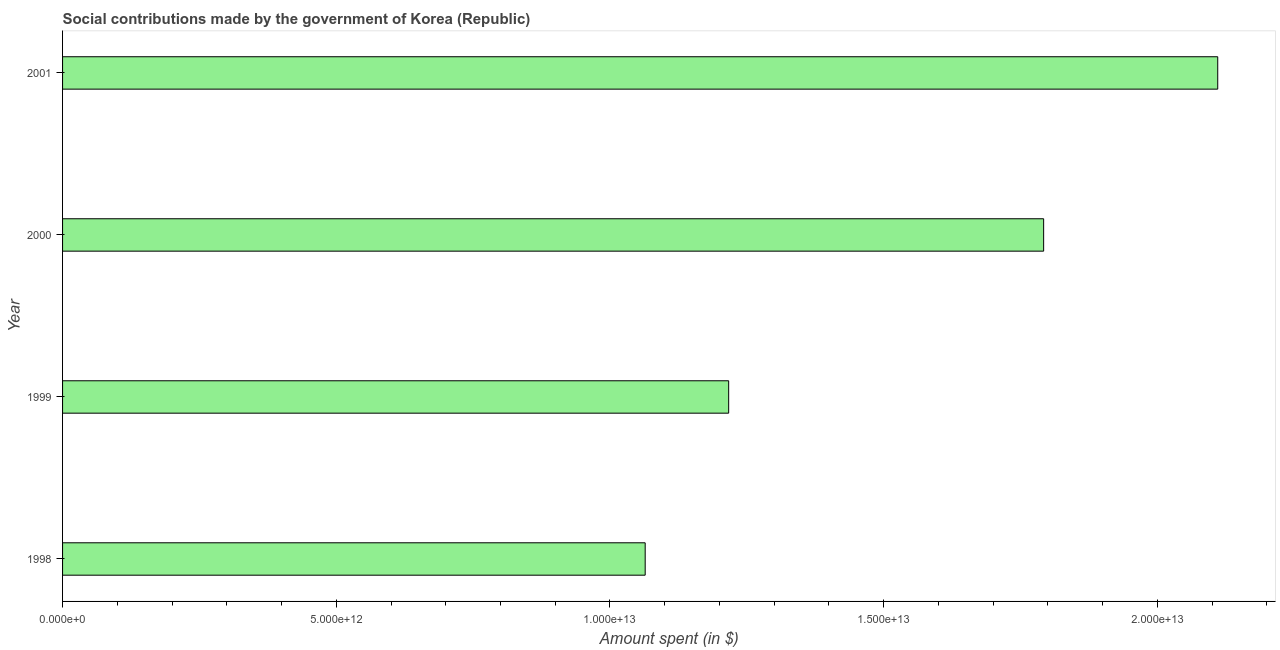Does the graph contain any zero values?
Make the answer very short. No. What is the title of the graph?
Provide a short and direct response. Social contributions made by the government of Korea (Republic). What is the label or title of the X-axis?
Offer a terse response. Amount spent (in $). What is the amount spent in making social contributions in 2001?
Give a very brief answer. 2.11e+13. Across all years, what is the maximum amount spent in making social contributions?
Your answer should be compact. 2.11e+13. Across all years, what is the minimum amount spent in making social contributions?
Ensure brevity in your answer.  1.06e+13. In which year was the amount spent in making social contributions minimum?
Offer a terse response. 1998. What is the sum of the amount spent in making social contributions?
Make the answer very short. 6.18e+13. What is the difference between the amount spent in making social contributions in 1998 and 1999?
Provide a succinct answer. -1.53e+12. What is the average amount spent in making social contributions per year?
Your answer should be compact. 1.55e+13. What is the median amount spent in making social contributions?
Offer a very short reply. 1.50e+13. In how many years, is the amount spent in making social contributions greater than 15000000000000 $?
Give a very brief answer. 2. Do a majority of the years between 1998 and 2000 (inclusive) have amount spent in making social contributions greater than 21000000000000 $?
Keep it short and to the point. No. What is the ratio of the amount spent in making social contributions in 1999 to that in 2000?
Ensure brevity in your answer.  0.68. Is the difference between the amount spent in making social contributions in 1998 and 2001 greater than the difference between any two years?
Give a very brief answer. Yes. What is the difference between the highest and the second highest amount spent in making social contributions?
Keep it short and to the point. 3.18e+12. Is the sum of the amount spent in making social contributions in 2000 and 2001 greater than the maximum amount spent in making social contributions across all years?
Your answer should be compact. Yes. What is the difference between the highest and the lowest amount spent in making social contributions?
Ensure brevity in your answer.  1.05e+13. Are all the bars in the graph horizontal?
Offer a very short reply. Yes. What is the difference between two consecutive major ticks on the X-axis?
Your answer should be compact. 5.00e+12. Are the values on the major ticks of X-axis written in scientific E-notation?
Provide a short and direct response. Yes. What is the Amount spent (in $) in 1998?
Provide a succinct answer. 1.06e+13. What is the Amount spent (in $) in 1999?
Your answer should be compact. 1.22e+13. What is the Amount spent (in $) in 2000?
Ensure brevity in your answer.  1.79e+13. What is the Amount spent (in $) of 2001?
Your answer should be very brief. 2.11e+13. What is the difference between the Amount spent (in $) in 1998 and 1999?
Your answer should be compact. -1.53e+12. What is the difference between the Amount spent (in $) in 1998 and 2000?
Your answer should be compact. -7.28e+12. What is the difference between the Amount spent (in $) in 1998 and 2001?
Keep it short and to the point. -1.05e+13. What is the difference between the Amount spent (in $) in 1999 and 2000?
Your answer should be compact. -5.75e+12. What is the difference between the Amount spent (in $) in 1999 and 2001?
Offer a terse response. -8.93e+12. What is the difference between the Amount spent (in $) in 2000 and 2001?
Your answer should be very brief. -3.18e+12. What is the ratio of the Amount spent (in $) in 1998 to that in 1999?
Ensure brevity in your answer.  0.88. What is the ratio of the Amount spent (in $) in 1998 to that in 2000?
Ensure brevity in your answer.  0.59. What is the ratio of the Amount spent (in $) in 1998 to that in 2001?
Your response must be concise. 0.5. What is the ratio of the Amount spent (in $) in 1999 to that in 2000?
Your response must be concise. 0.68. What is the ratio of the Amount spent (in $) in 1999 to that in 2001?
Give a very brief answer. 0.58. What is the ratio of the Amount spent (in $) in 2000 to that in 2001?
Give a very brief answer. 0.85. 